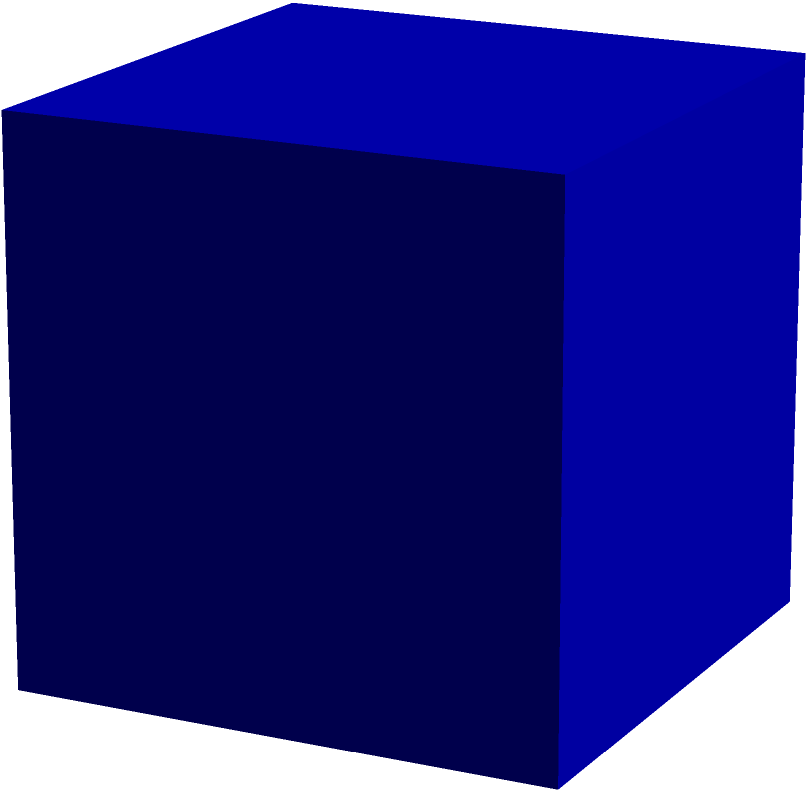A cube-shaped shipping container is used to transport electronic components for a new stock trading system. If the surface area of the container is 54 square feet, what is the length of each edge of the cube in feet? Let's approach this step-by-step:

1) First, recall the formula for the surface area of a cube:
   Surface Area = $6a^2$, where $a$ is the length of an edge.

2) We're given that the surface area is 54 square feet. Let's plug this into our formula:
   $54 = 6a^2$

3) Now, let's solve for $a$:
   $\frac{54}{6} = a^2$
   $9 = a^2$

4) To find $a$, we need to take the square root of both sides:
   $\sqrt{9} = a$
   $3 = a$

5) Therefore, the length of each edge of the cube is 3 feet.

This problem relates to your work as a stock trader because it demonstrates how basic geometry can be applied to real-world logistics problems in the financial industry, such as shipping equipment for trading systems.
Answer: 3 feet 